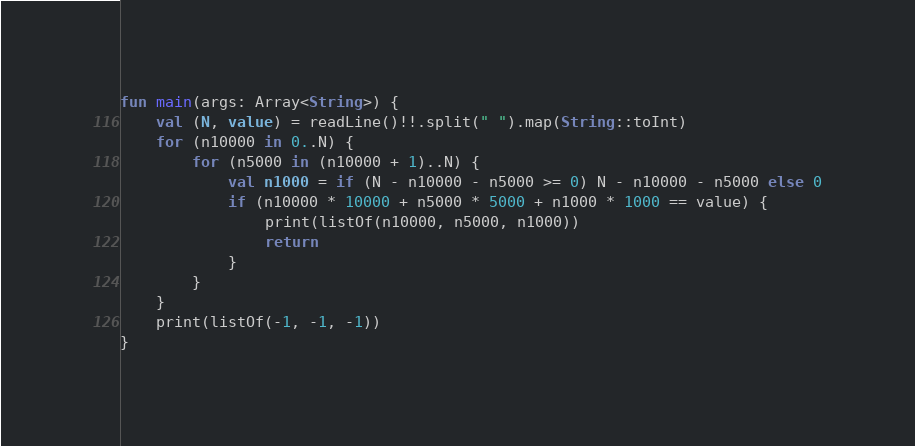<code> <loc_0><loc_0><loc_500><loc_500><_Kotlin_>fun main(args: Array<String>) {
    val (N, value) = readLine()!!.split(" ").map(String::toInt)
    for (n10000 in 0..N) {
        for (n5000 in (n10000 + 1)..N) {
            val n1000 = if (N - n10000 - n5000 >= 0) N - n10000 - n5000 else 0
            if (n10000 * 10000 + n5000 * 5000 + n1000 * 1000 == value) {
                print(listOf(n10000, n5000, n1000))
                return
            }
        }
    }
    print(listOf(-1, -1, -1))
}</code> 